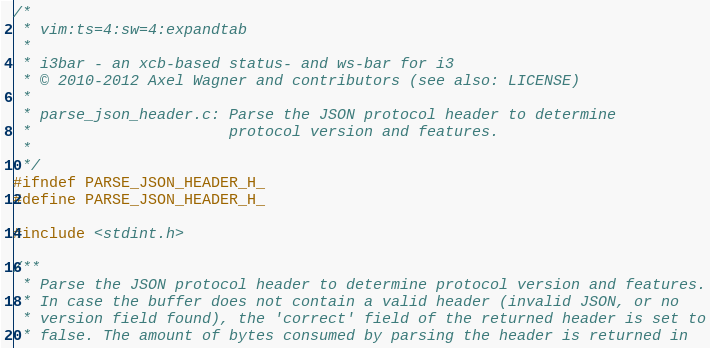<code> <loc_0><loc_0><loc_500><loc_500><_C_>/*
 * vim:ts=4:sw=4:expandtab
 *
 * i3bar - an xcb-based status- and ws-bar for i3
 * © 2010-2012 Axel Wagner and contributors (see also: LICENSE)
 *
 * parse_json_header.c: Parse the JSON protocol header to determine
 *                      protocol version and features.
 *
 */
#ifndef PARSE_JSON_HEADER_H_
#define PARSE_JSON_HEADER_H_

#include <stdint.h>

/**
 * Parse the JSON protocol header to determine protocol version and features.
 * In case the buffer does not contain a valid header (invalid JSON, or no
 * version field found), the 'correct' field of the returned header is set to
 * false. The amount of bytes consumed by parsing the header is returned in</code> 